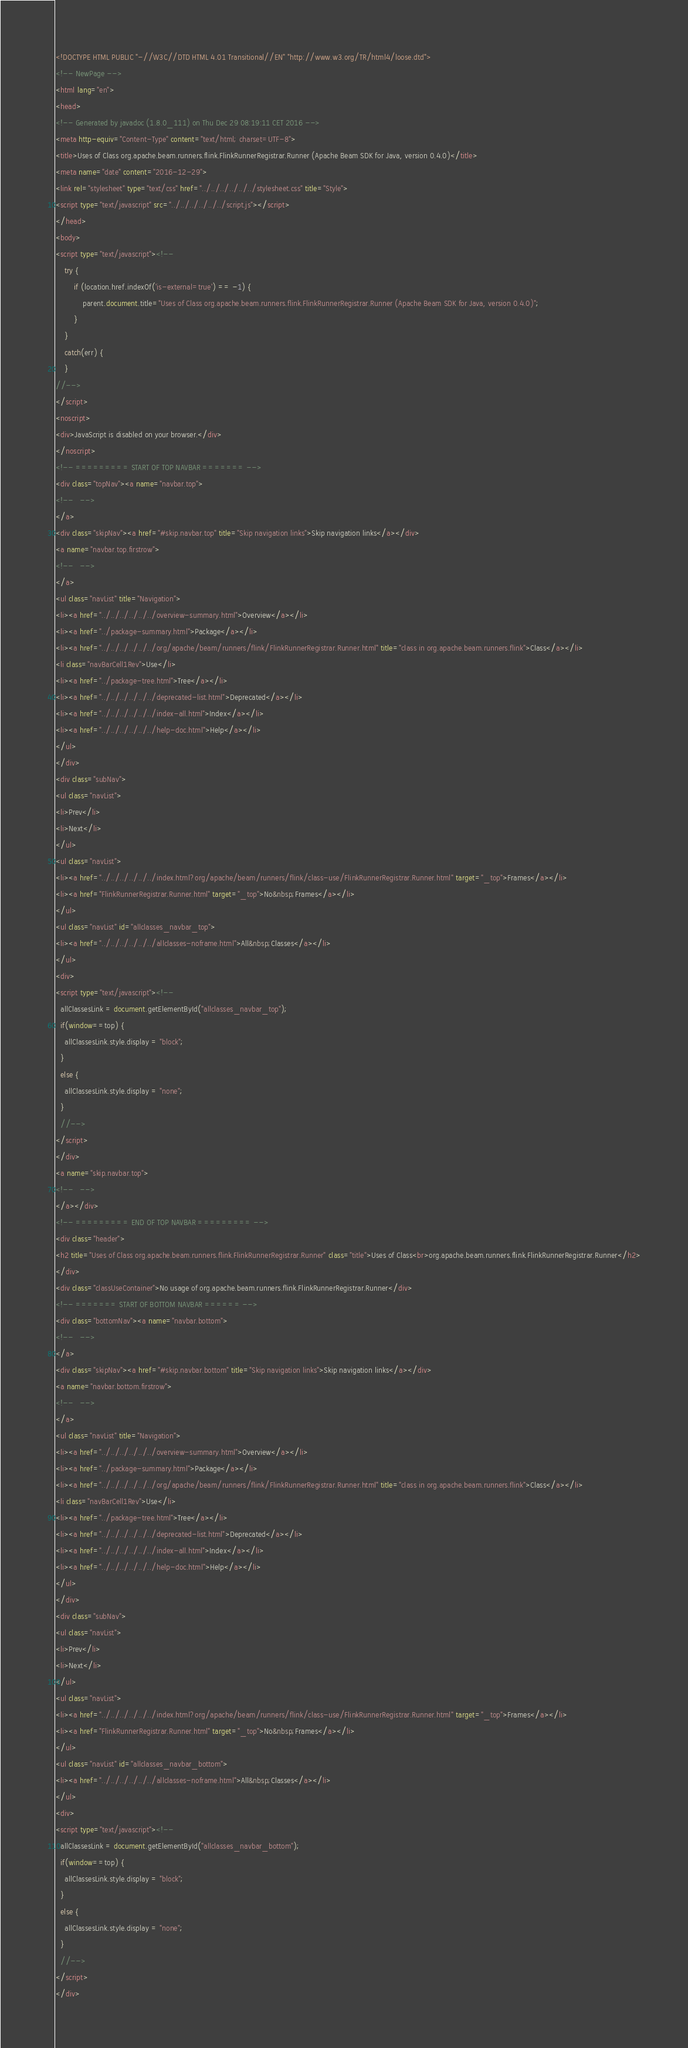Convert code to text. <code><loc_0><loc_0><loc_500><loc_500><_HTML_><!DOCTYPE HTML PUBLIC "-//W3C//DTD HTML 4.01 Transitional//EN" "http://www.w3.org/TR/html4/loose.dtd">
<!-- NewPage -->
<html lang="en">
<head>
<!-- Generated by javadoc (1.8.0_111) on Thu Dec 29 08:19:11 CET 2016 -->
<meta http-equiv="Content-Type" content="text/html; charset=UTF-8">
<title>Uses of Class org.apache.beam.runners.flink.FlinkRunnerRegistrar.Runner (Apache Beam SDK for Java, version 0.4.0)</title>
<meta name="date" content="2016-12-29">
<link rel="stylesheet" type="text/css" href="../../../../../../stylesheet.css" title="Style">
<script type="text/javascript" src="../../../../../../script.js"></script>
</head>
<body>
<script type="text/javascript"><!--
    try {
        if (location.href.indexOf('is-external=true') == -1) {
            parent.document.title="Uses of Class org.apache.beam.runners.flink.FlinkRunnerRegistrar.Runner (Apache Beam SDK for Java, version 0.4.0)";
        }
    }
    catch(err) {
    }
//-->
</script>
<noscript>
<div>JavaScript is disabled on your browser.</div>
</noscript>
<!-- ========= START OF TOP NAVBAR ======= -->
<div class="topNav"><a name="navbar.top">
<!--   -->
</a>
<div class="skipNav"><a href="#skip.navbar.top" title="Skip navigation links">Skip navigation links</a></div>
<a name="navbar.top.firstrow">
<!--   -->
</a>
<ul class="navList" title="Navigation">
<li><a href="../../../../../../overview-summary.html">Overview</a></li>
<li><a href="../package-summary.html">Package</a></li>
<li><a href="../../../../../../org/apache/beam/runners/flink/FlinkRunnerRegistrar.Runner.html" title="class in org.apache.beam.runners.flink">Class</a></li>
<li class="navBarCell1Rev">Use</li>
<li><a href="../package-tree.html">Tree</a></li>
<li><a href="../../../../../../deprecated-list.html">Deprecated</a></li>
<li><a href="../../../../../../index-all.html">Index</a></li>
<li><a href="../../../../../../help-doc.html">Help</a></li>
</ul>
</div>
<div class="subNav">
<ul class="navList">
<li>Prev</li>
<li>Next</li>
</ul>
<ul class="navList">
<li><a href="../../../../../../index.html?org/apache/beam/runners/flink/class-use/FlinkRunnerRegistrar.Runner.html" target="_top">Frames</a></li>
<li><a href="FlinkRunnerRegistrar.Runner.html" target="_top">No&nbsp;Frames</a></li>
</ul>
<ul class="navList" id="allclasses_navbar_top">
<li><a href="../../../../../../allclasses-noframe.html">All&nbsp;Classes</a></li>
</ul>
<div>
<script type="text/javascript"><!--
  allClassesLink = document.getElementById("allclasses_navbar_top");
  if(window==top) {
    allClassesLink.style.display = "block";
  }
  else {
    allClassesLink.style.display = "none";
  }
  //-->
</script>
</div>
<a name="skip.navbar.top">
<!--   -->
</a></div>
<!-- ========= END OF TOP NAVBAR ========= -->
<div class="header">
<h2 title="Uses of Class org.apache.beam.runners.flink.FlinkRunnerRegistrar.Runner" class="title">Uses of Class<br>org.apache.beam.runners.flink.FlinkRunnerRegistrar.Runner</h2>
</div>
<div class="classUseContainer">No usage of org.apache.beam.runners.flink.FlinkRunnerRegistrar.Runner</div>
<!-- ======= START OF BOTTOM NAVBAR ====== -->
<div class="bottomNav"><a name="navbar.bottom">
<!--   -->
</a>
<div class="skipNav"><a href="#skip.navbar.bottom" title="Skip navigation links">Skip navigation links</a></div>
<a name="navbar.bottom.firstrow">
<!--   -->
</a>
<ul class="navList" title="Navigation">
<li><a href="../../../../../../overview-summary.html">Overview</a></li>
<li><a href="../package-summary.html">Package</a></li>
<li><a href="../../../../../../org/apache/beam/runners/flink/FlinkRunnerRegistrar.Runner.html" title="class in org.apache.beam.runners.flink">Class</a></li>
<li class="navBarCell1Rev">Use</li>
<li><a href="../package-tree.html">Tree</a></li>
<li><a href="../../../../../../deprecated-list.html">Deprecated</a></li>
<li><a href="../../../../../../index-all.html">Index</a></li>
<li><a href="../../../../../../help-doc.html">Help</a></li>
</ul>
</div>
<div class="subNav">
<ul class="navList">
<li>Prev</li>
<li>Next</li>
</ul>
<ul class="navList">
<li><a href="../../../../../../index.html?org/apache/beam/runners/flink/class-use/FlinkRunnerRegistrar.Runner.html" target="_top">Frames</a></li>
<li><a href="FlinkRunnerRegistrar.Runner.html" target="_top">No&nbsp;Frames</a></li>
</ul>
<ul class="navList" id="allclasses_navbar_bottom">
<li><a href="../../../../../../allclasses-noframe.html">All&nbsp;Classes</a></li>
</ul>
<div>
<script type="text/javascript"><!--
  allClassesLink = document.getElementById("allclasses_navbar_bottom");
  if(window==top) {
    allClassesLink.style.display = "block";
  }
  else {
    allClassesLink.style.display = "none";
  }
  //-->
</script>
</div></code> 